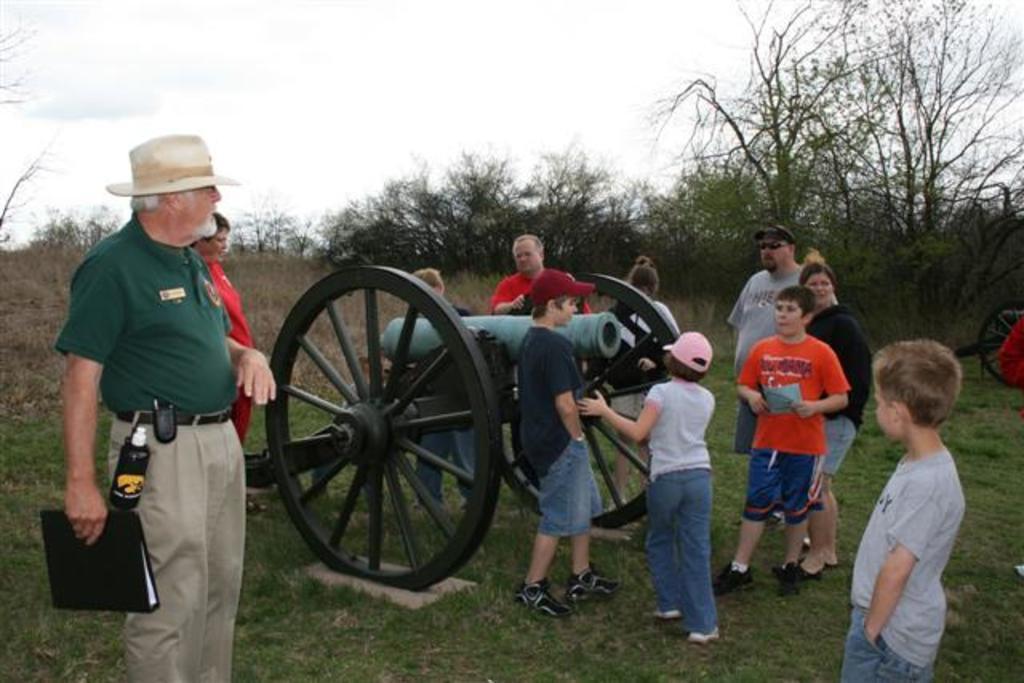Could you give a brief overview of what you see in this image? In this image in the center there are group of persons standing and there is a cannon in the center. There is grass on the ground. In the background there are trees and the sky is cloudy. On the left side there is a man standing and holding an object which is black in colour in his hand and wearing a cream colour hat. 